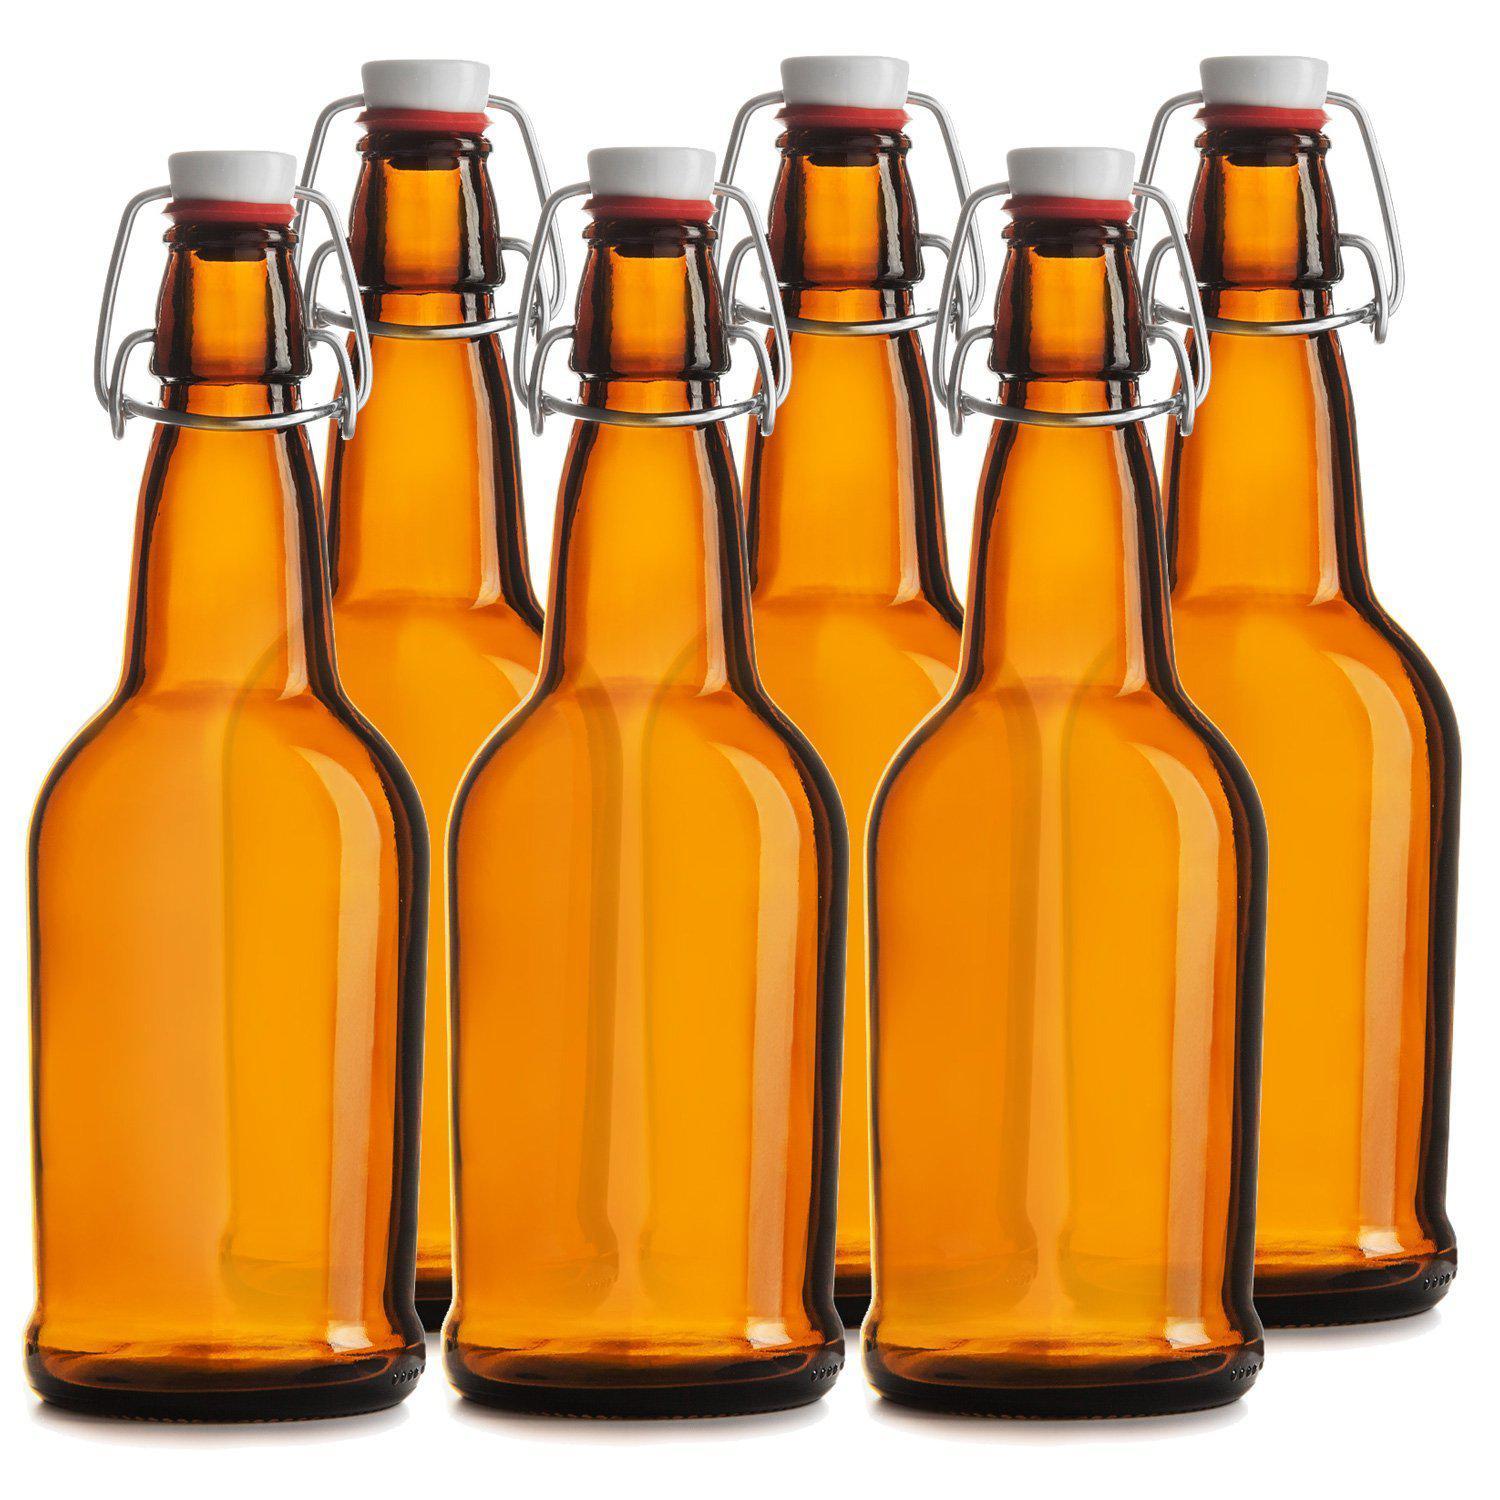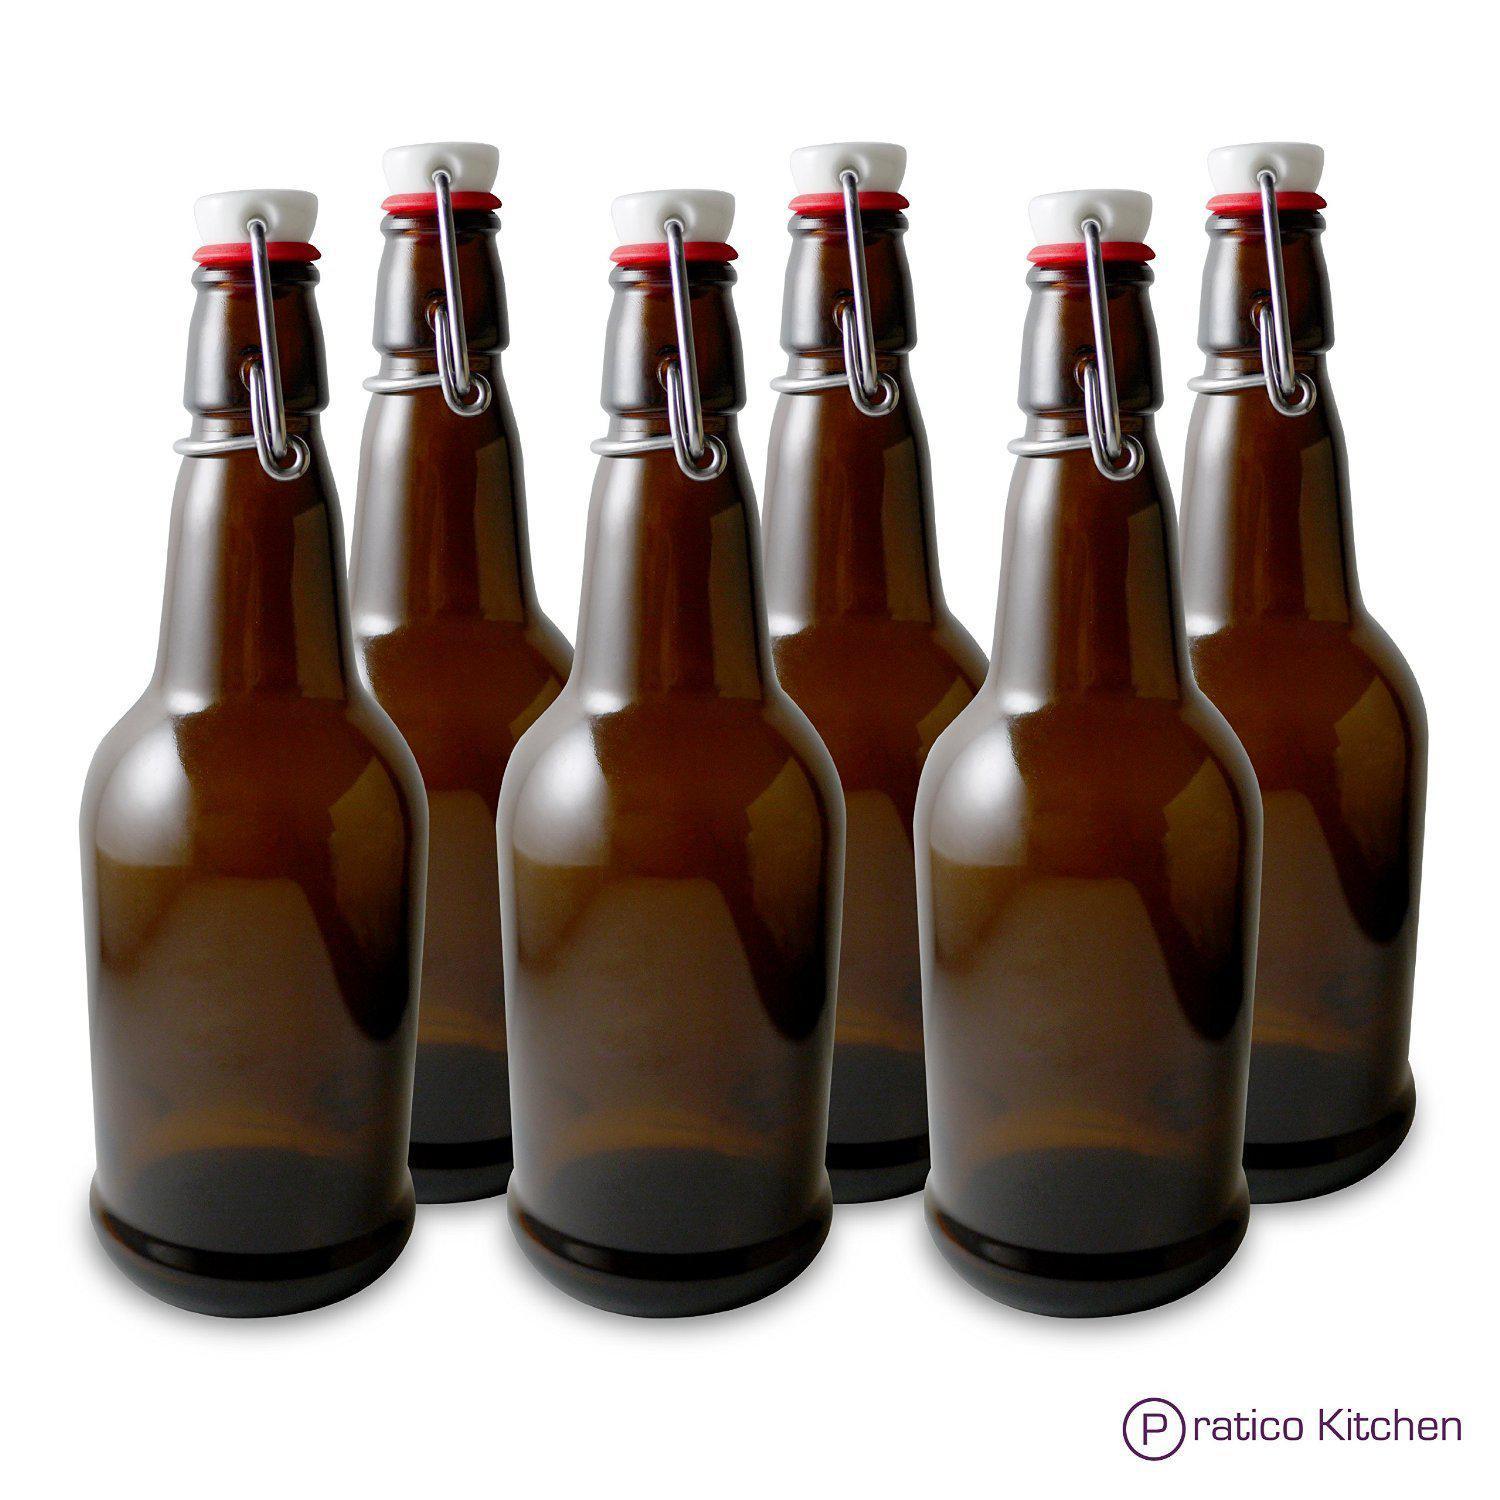The first image is the image on the left, the second image is the image on the right. Given the left and right images, does the statement "No bottles have labels or metal openers on top." hold true? Answer yes or no. No. The first image is the image on the left, the second image is the image on the right. Assess this claim about the two images: "The bottles are of two colors and none have lables.". Correct or not? Answer yes or no. Yes. 